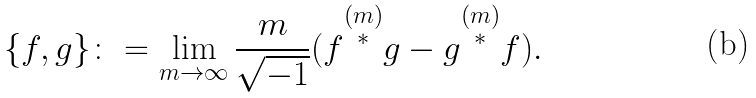Convert formula to latex. <formula><loc_0><loc_0><loc_500><loc_500>\{ f , g \} \colon = \lim _ { m \to \infty } \frac { m } { \sqrt { - 1 } } ( f \overset { ( m ) } { ^ { * } } g - g \overset { ( m ) } { ^ { * } } f ) .</formula> 